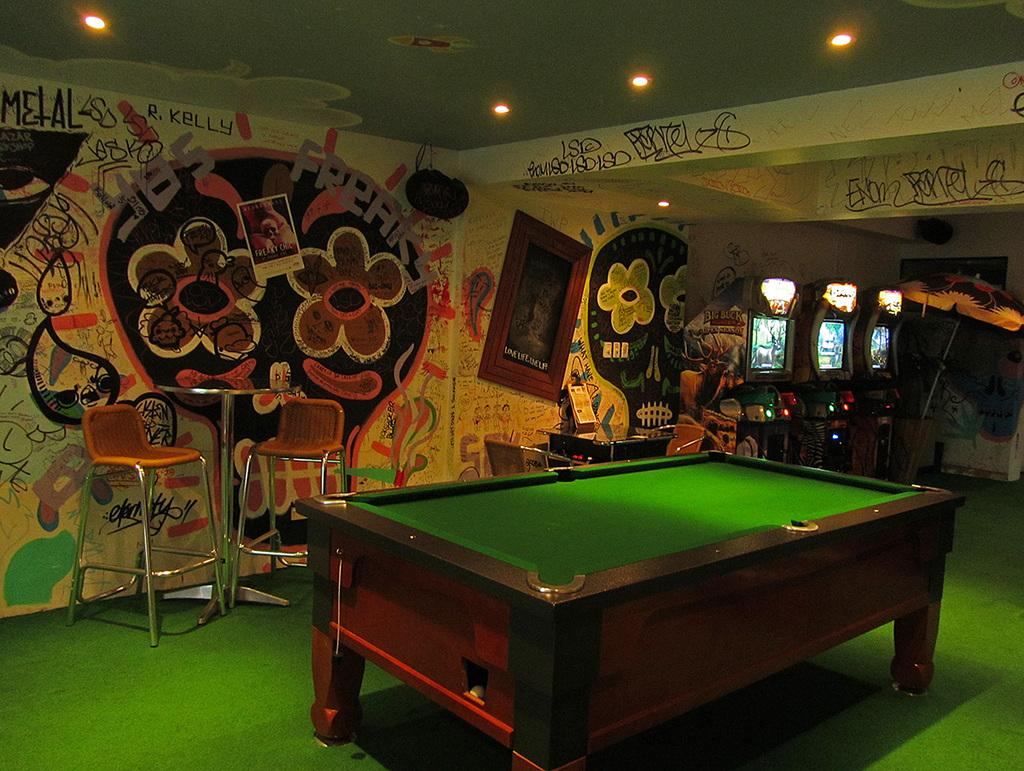What is on the floor in the image? There is a table on the floor in the image. What can be seen on the wall in the image? Paintings and photo frames are present on the wall in the image. What is above the wall in the image? There is a roof in the image. What is providing illumination in the image? Lights are present in the image. What type of twist is being performed on the table in the image? There is no twist being performed in the image; it is a still image of a table, wall, paintings, photo frames, roof, and lights. What is being served for breakfast in the image? There is no mention of breakfast or any food items in the image. 